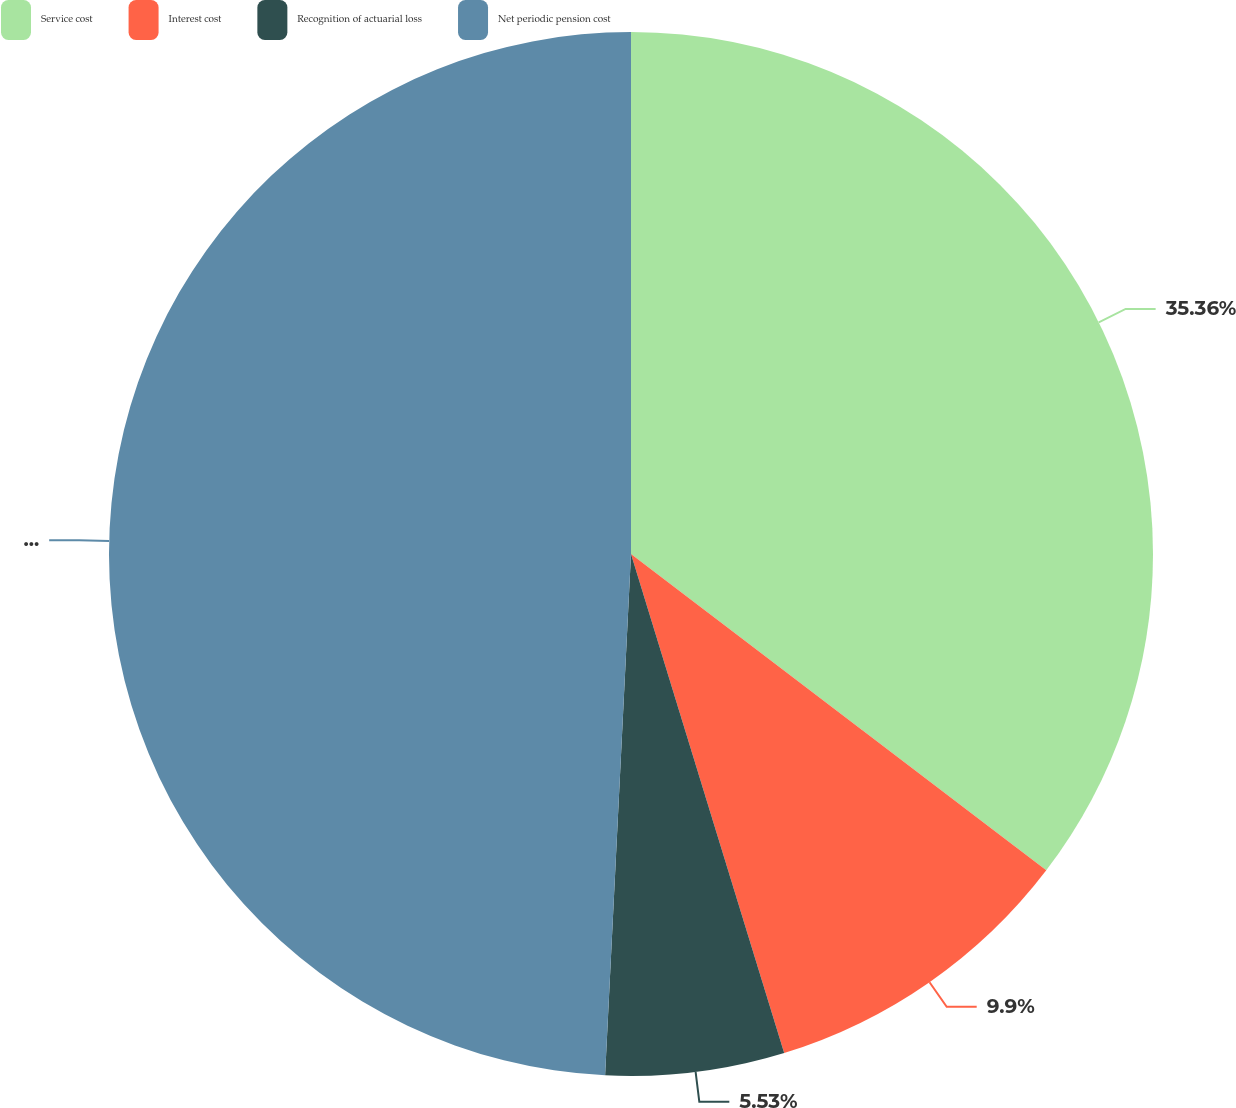Convert chart to OTSL. <chart><loc_0><loc_0><loc_500><loc_500><pie_chart><fcel>Service cost<fcel>Interest cost<fcel>Recognition of actuarial loss<fcel>Net periodic pension cost<nl><fcel>35.36%<fcel>9.9%<fcel>5.53%<fcel>49.21%<nl></chart> 